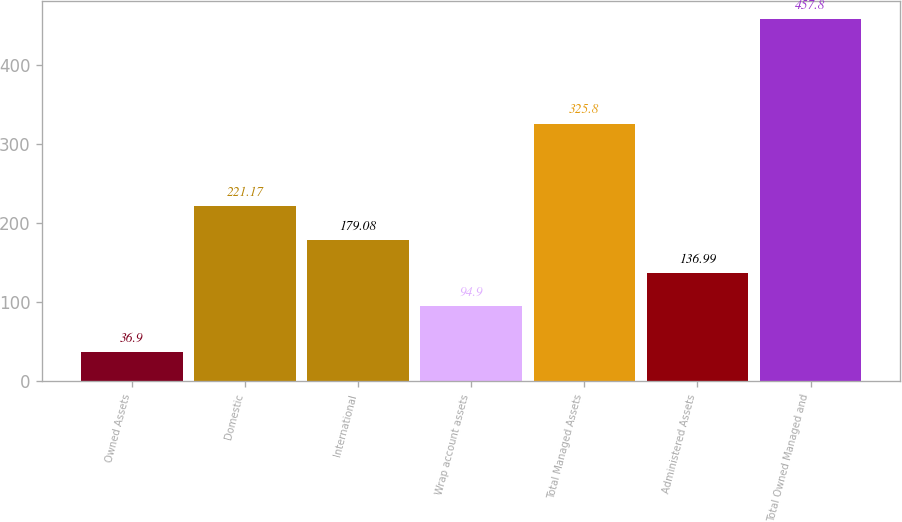Convert chart. <chart><loc_0><loc_0><loc_500><loc_500><bar_chart><fcel>Owned Assets<fcel>Domestic<fcel>International<fcel>Wrap account assets<fcel>Total Managed Assets<fcel>Administered Assets<fcel>Total Owned Managed and<nl><fcel>36.9<fcel>221.17<fcel>179.08<fcel>94.9<fcel>325.8<fcel>136.99<fcel>457.8<nl></chart> 